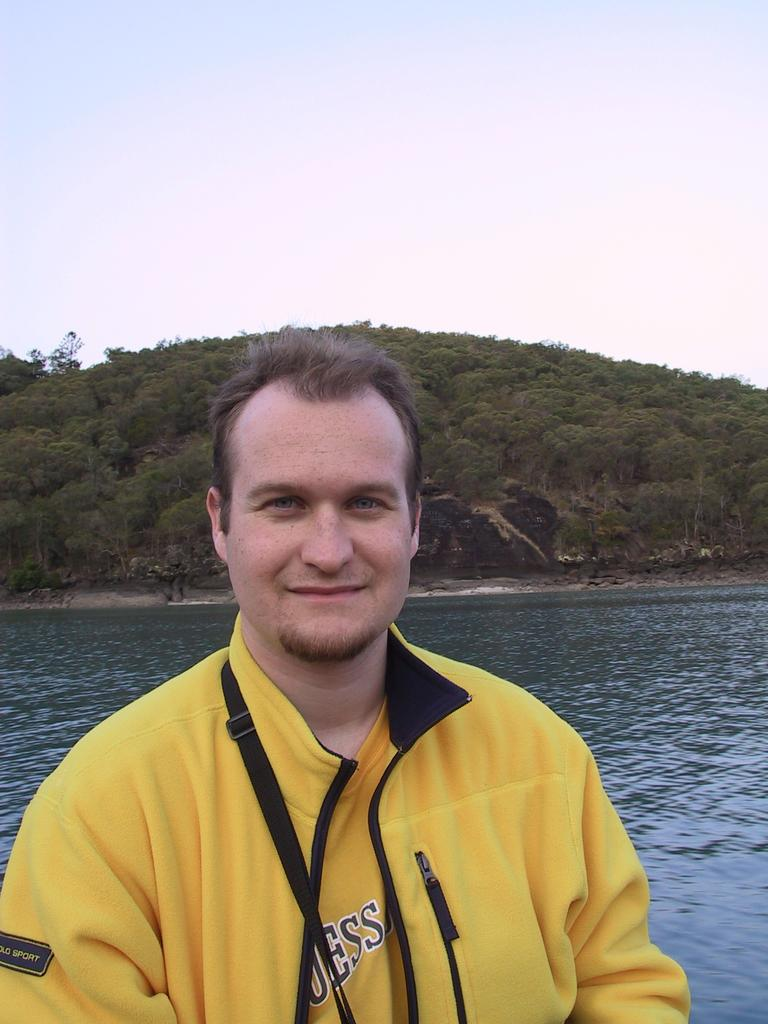Provide a one-sentence caption for the provided image. A man stands in front of water wearing a yellow shirt with letters, "ESS" on the front. 